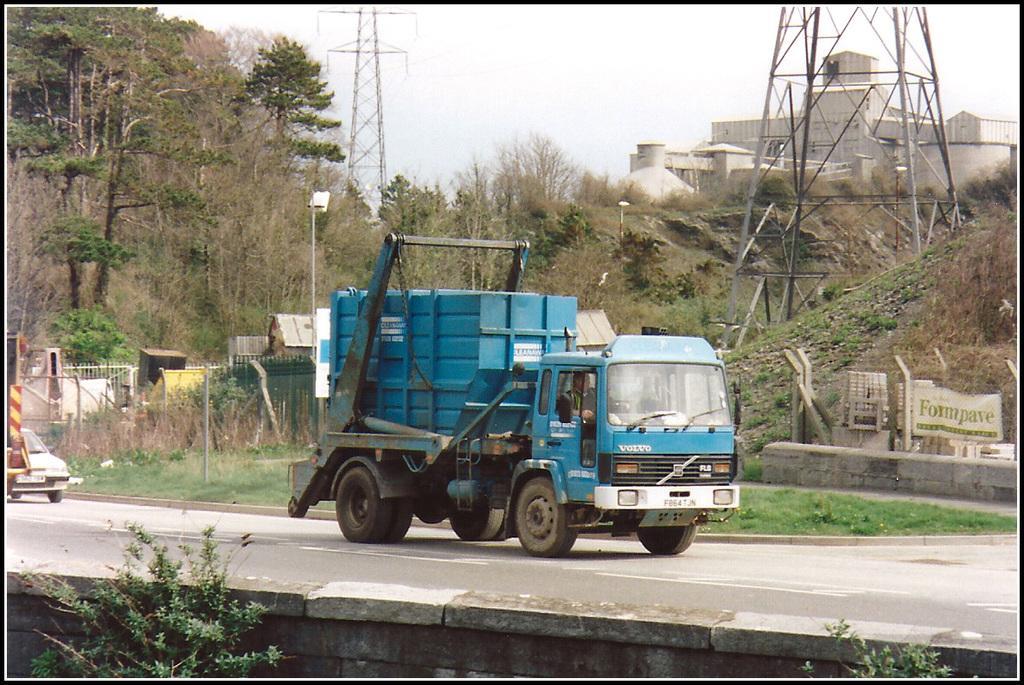Could you give a brief overview of what you see in this image? In the picture we can see a road beside it, we can see some plants and on the road we can see a truck with a blue color garbage box on it and behind the truck we can see a car which is white in color and in the background, we can see grass surface, plants, trees and towers with wires and behind it we can see a house building which is white in color and we can see a sky. 